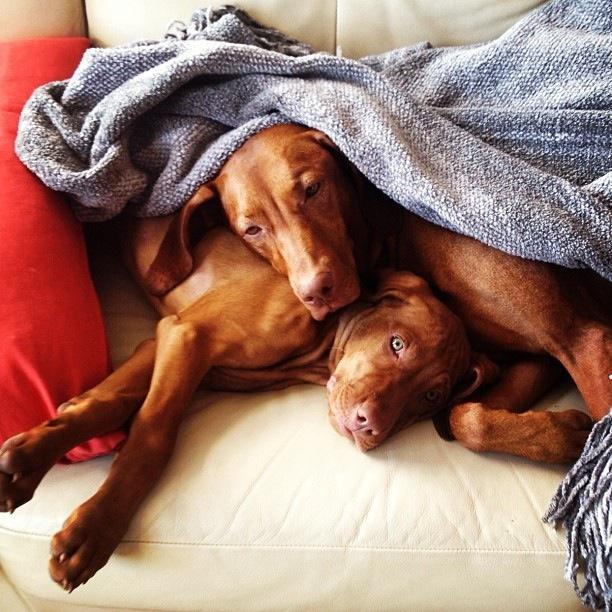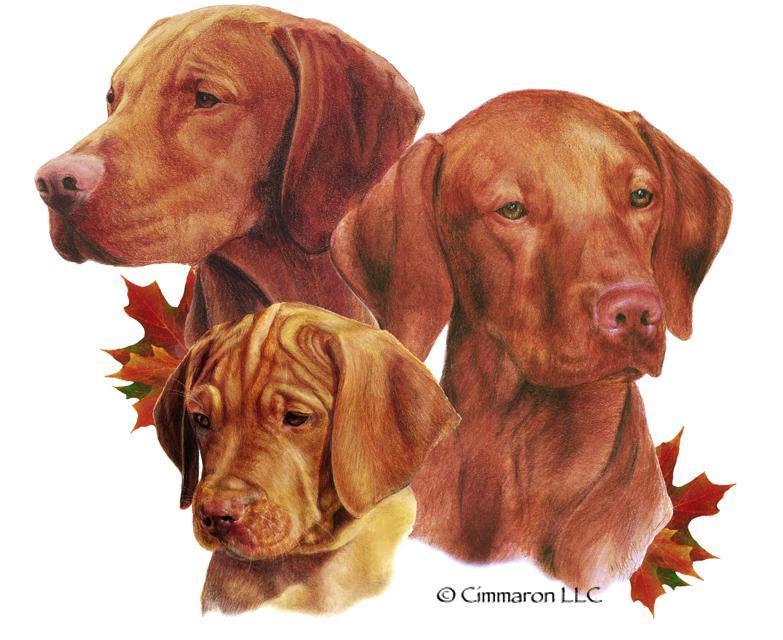The first image is the image on the left, the second image is the image on the right. Considering the images on both sides, is "The right image shows multiple dogs in a container, with at least one paw over the edge on each side." valid? Answer yes or no. No. The first image is the image on the left, the second image is the image on the right. Examine the images to the left and right. Is the description "There are 3 or more dogs in one of the images." accurate? Answer yes or no. Yes. 